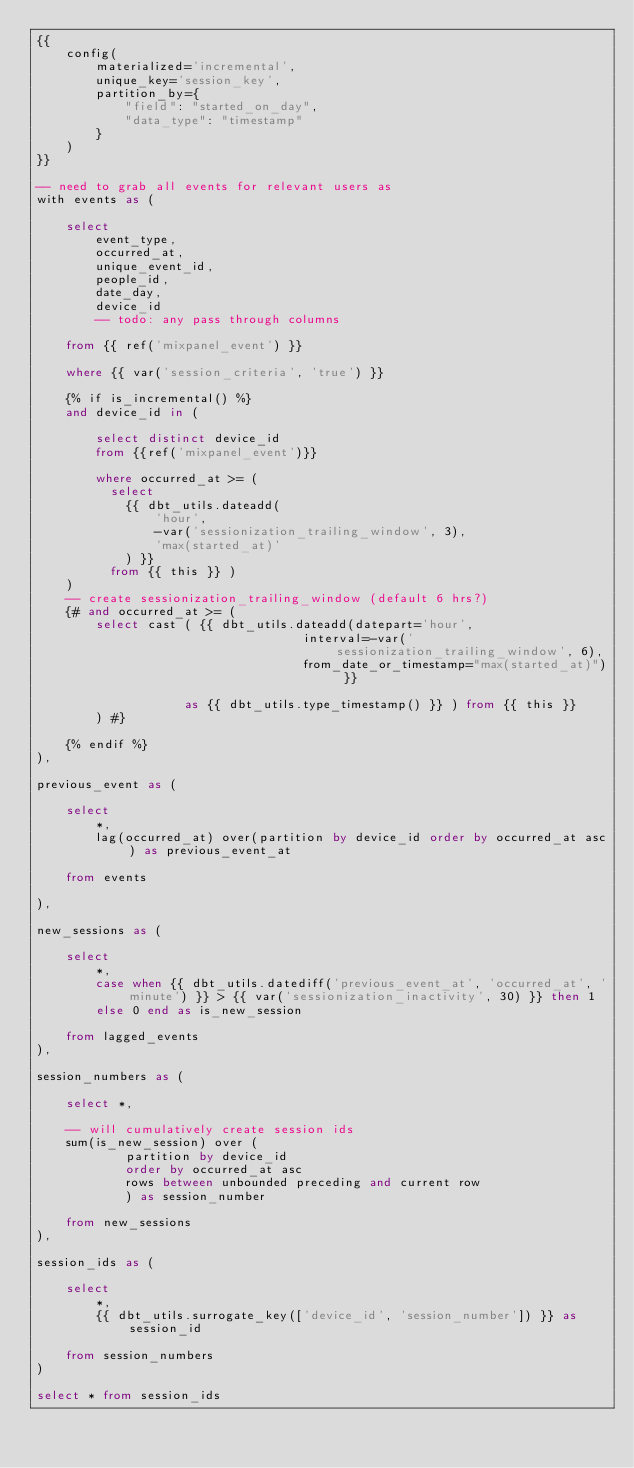<code> <loc_0><loc_0><loc_500><loc_500><_SQL_>{{
    config(
        materialized='incremental',
        unique_key='session_key',
        partition_by={
            "field": "started_on_day",
            "data_type": "timestamp"
        }
    )
}}

-- need to grab all events for relevant users as 
with events as (

    select 
        event_type,
        occurred_at,
        unique_event_id,
        people_id,
        date_day,
        device_id
        -- todo: any pass through columns

    from {{ ref('mixpanel_event') }}

    where {{ var('session_criteria', 'true') }} 

    {% if is_incremental() %}
    and device_id in (

        select distinct device_id
        from {{ref('mixpanel_event')}}

        where occurred_at >= (
          select
            {{ dbt_utils.dateadd(
                'hour',
                -var('sessionization_trailing_window', 3),
                'max(started_at)'
            ) }}
          from {{ this }} )
    )
    -- create sessionization_trailing_window (default 6 hrs?)
    {# and occurred_at >= (
        select cast ( {{ dbt_utils.dateadd(datepart='hour', 
                                    interval=-var('sessionization_trailing_window', 6), 
                                    from_date_or_timestamp="max(started_at)") }} 

                    as {{ dbt_utils.type_timestamp() }} ) from {{ this }} 
        ) #}

    {% endif %}
),

previous_event as (

    select 
        *,
        lag(occurred_at) over(partition by device_id order by occurred_at asc) as previous_event_at

    from events 

),

new_sessions as (
    
    select 
        *,
        case when {{ dbt_utils.datediff('previous_event_at', 'occurred_at', 'minute') }} > {{ var('sessionization_inactivity', 30) }} then 1
        else 0 end as is_new_session

    from lagged_events
),

session_numbers as (

    select *,

    -- will cumulatively create session ids
    sum(is_new_session) over (
            partition by device_id
            order by occurred_at asc
            rows between unbounded preceding and current row
            ) as session_number

    from new_sessions
),

session_ids as (

    select
        *,
        {{ dbt_utils.surrogate_key(['device_id', 'session_number']) }} as session_id

    from session_numbers
)

select * from session_ids
</code> 